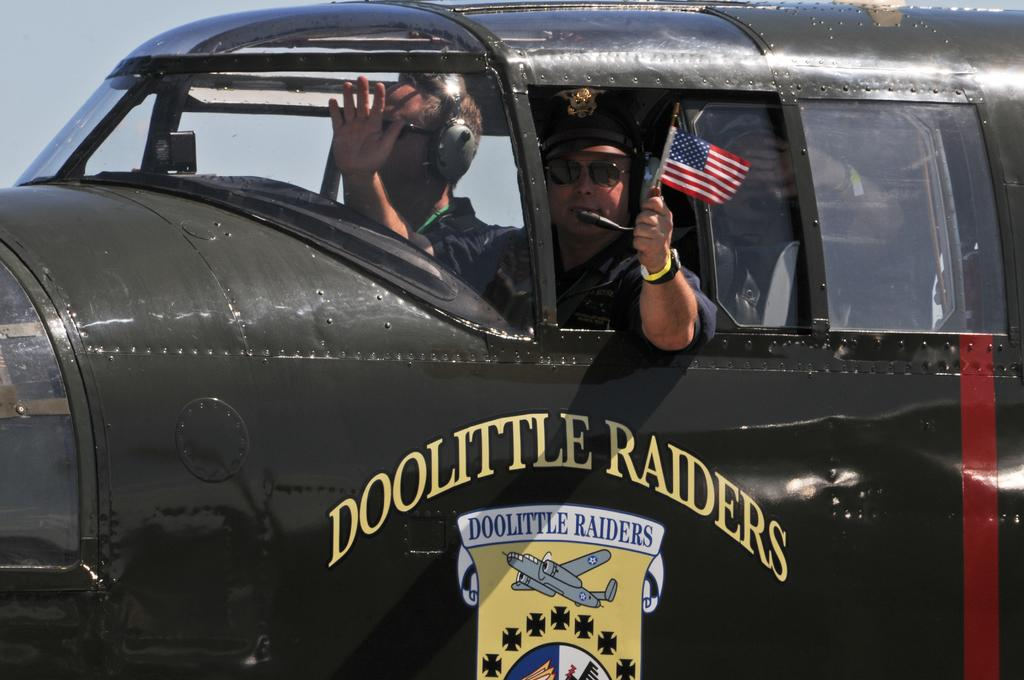Who is present in the image? There are people in the image. What are the people doing in the image? The people are traveling in a vehicle. Can you describe any specific actions or objects related to the people in the image? One person is holding a flag. What type of zebra can be seen playing an instrument in the image? There is no zebra or instrument present in the image. What type of business is being conducted in the image? The image does not depict any business activities; it shows people traveling in a vehicle. 